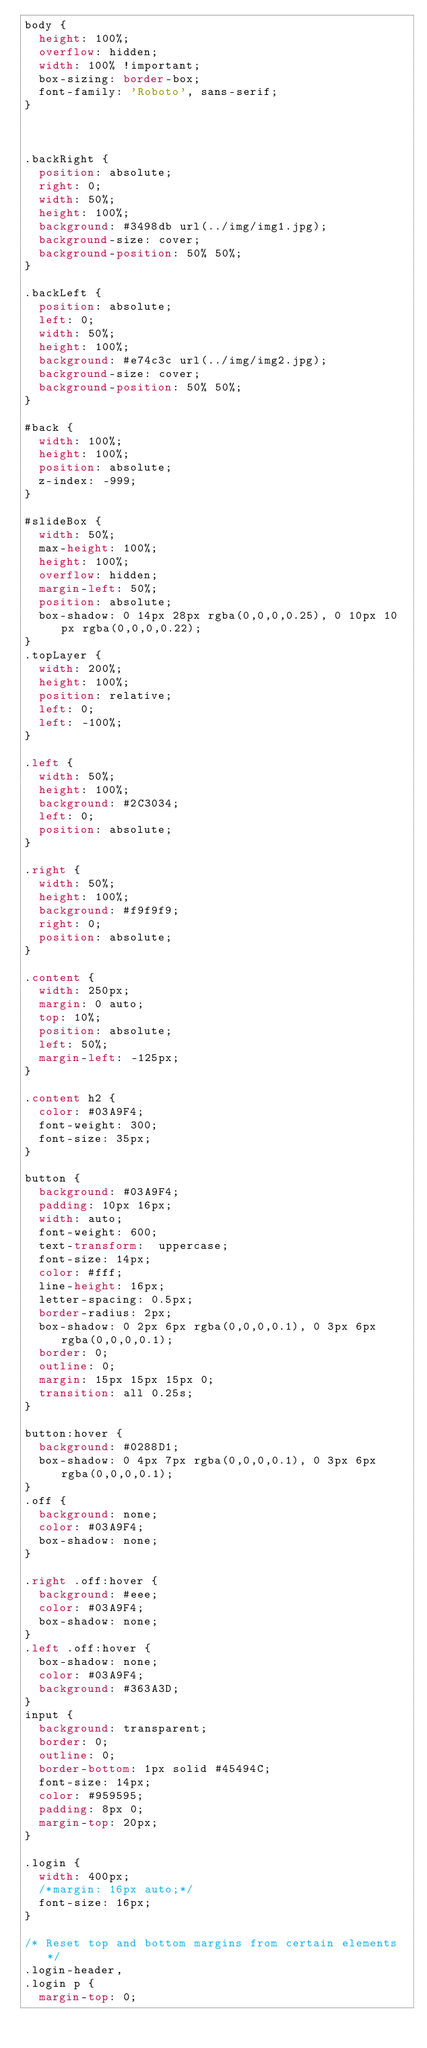Convert code to text. <code><loc_0><loc_0><loc_500><loc_500><_CSS_>body {
  height: 100%;
  overflow: hidden;
  width: 100% !important;
  box-sizing: border-box;
  font-family: 'Roboto', sans-serif;
}



.backRight {
  position: absolute;
  right: 0;
  width: 50%;
  height: 100%;
  background: #3498db url(../img/img1.jpg);
  background-size: cover;
  background-position: 50% 50%;
}

.backLeft {
  position: absolute;
  left: 0;
  width: 50%;
  height: 100%;
  background: #e74c3c url(../img/img2.jpg);
  background-size: cover;
  background-position: 50% 50%;
}

#back {
  width: 100%;
  height: 100%;
  position: absolute;
  z-index: -999;
}

#slideBox {
  width: 50%;
  max-height: 100%;
  height: 100%;
  overflow: hidden;
  margin-left: 50%;
  position: absolute;
  box-shadow: 0 14px 28px rgba(0,0,0,0.25), 0 10px 10px rgba(0,0,0,0.22);
}
.topLayer {
  width: 200%;
  height: 100%;
  position: relative;
  left: 0;
  left: -100%;
}

.left {
  width: 50%;
  height: 100%;
  background: #2C3034;
  left: 0;
  position: absolute;
}

.right {
  width: 50%;
  height: 100%;
  background: #f9f9f9;
  right: 0;
  position: absolute;
}

.content {
  width: 250px;
  margin: 0 auto;
  top: 10%;
  position: absolute;
  left: 50%;
  margin-left: -125px;
}

.content h2 {
  color: #03A9F4;
  font-weight: 300;
  font-size: 35px;
}

button {
  background: #03A9F4;
  padding: 10px 16px;
  width: auto;
  font-weight: 600;
  text-transform:  uppercase;
  font-size: 14px;
  color: #fff;
  line-height: 16px;
  letter-spacing: 0.5px;
  border-radius: 2px;
  box-shadow: 0 2px 6px rgba(0,0,0,0.1), 0 3px 6px rgba(0,0,0,0.1);
  border: 0;
  outline: 0;
  margin: 15px 15px 15px 0;
  transition: all 0.25s;
}

button:hover {
  background: #0288D1;
  box-shadow: 0 4px 7px rgba(0,0,0,0.1), 0 3px 6px rgba(0,0,0,0.1);
}
.off {
  background: none;
  color: #03A9F4;
  box-shadow: none;
}

.right .off:hover {
  background: #eee;
  color: #03A9F4;
  box-shadow: none;
}
.left .off:hover {
  box-shadow: none;
  color: #03A9F4;
  background: #363A3D;
}
input {
  background: transparent;
  border: 0;
  outline: 0;
  border-bottom: 1px solid #45494C;
  font-size: 14px;
  color: #959595;
  padding: 8px 0;
  margin-top: 20px;
}

.login {
  width: 400px;
  /*margin: 16px auto;*/
  font-size: 16px;
}

/* Reset top and bottom margins from certain elements */
.login-header,
.login p {
  margin-top: 0;</code> 